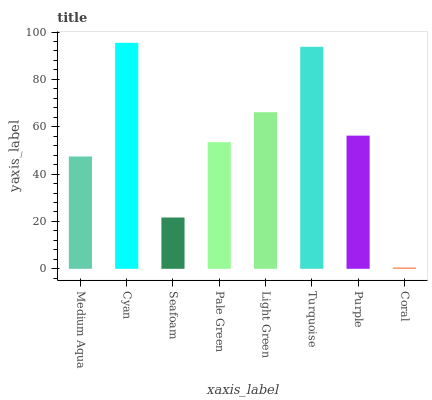Is Coral the minimum?
Answer yes or no. Yes. Is Cyan the maximum?
Answer yes or no. Yes. Is Seafoam the minimum?
Answer yes or no. No. Is Seafoam the maximum?
Answer yes or no. No. Is Cyan greater than Seafoam?
Answer yes or no. Yes. Is Seafoam less than Cyan?
Answer yes or no. Yes. Is Seafoam greater than Cyan?
Answer yes or no. No. Is Cyan less than Seafoam?
Answer yes or no. No. Is Purple the high median?
Answer yes or no. Yes. Is Pale Green the low median?
Answer yes or no. Yes. Is Medium Aqua the high median?
Answer yes or no. No. Is Coral the low median?
Answer yes or no. No. 